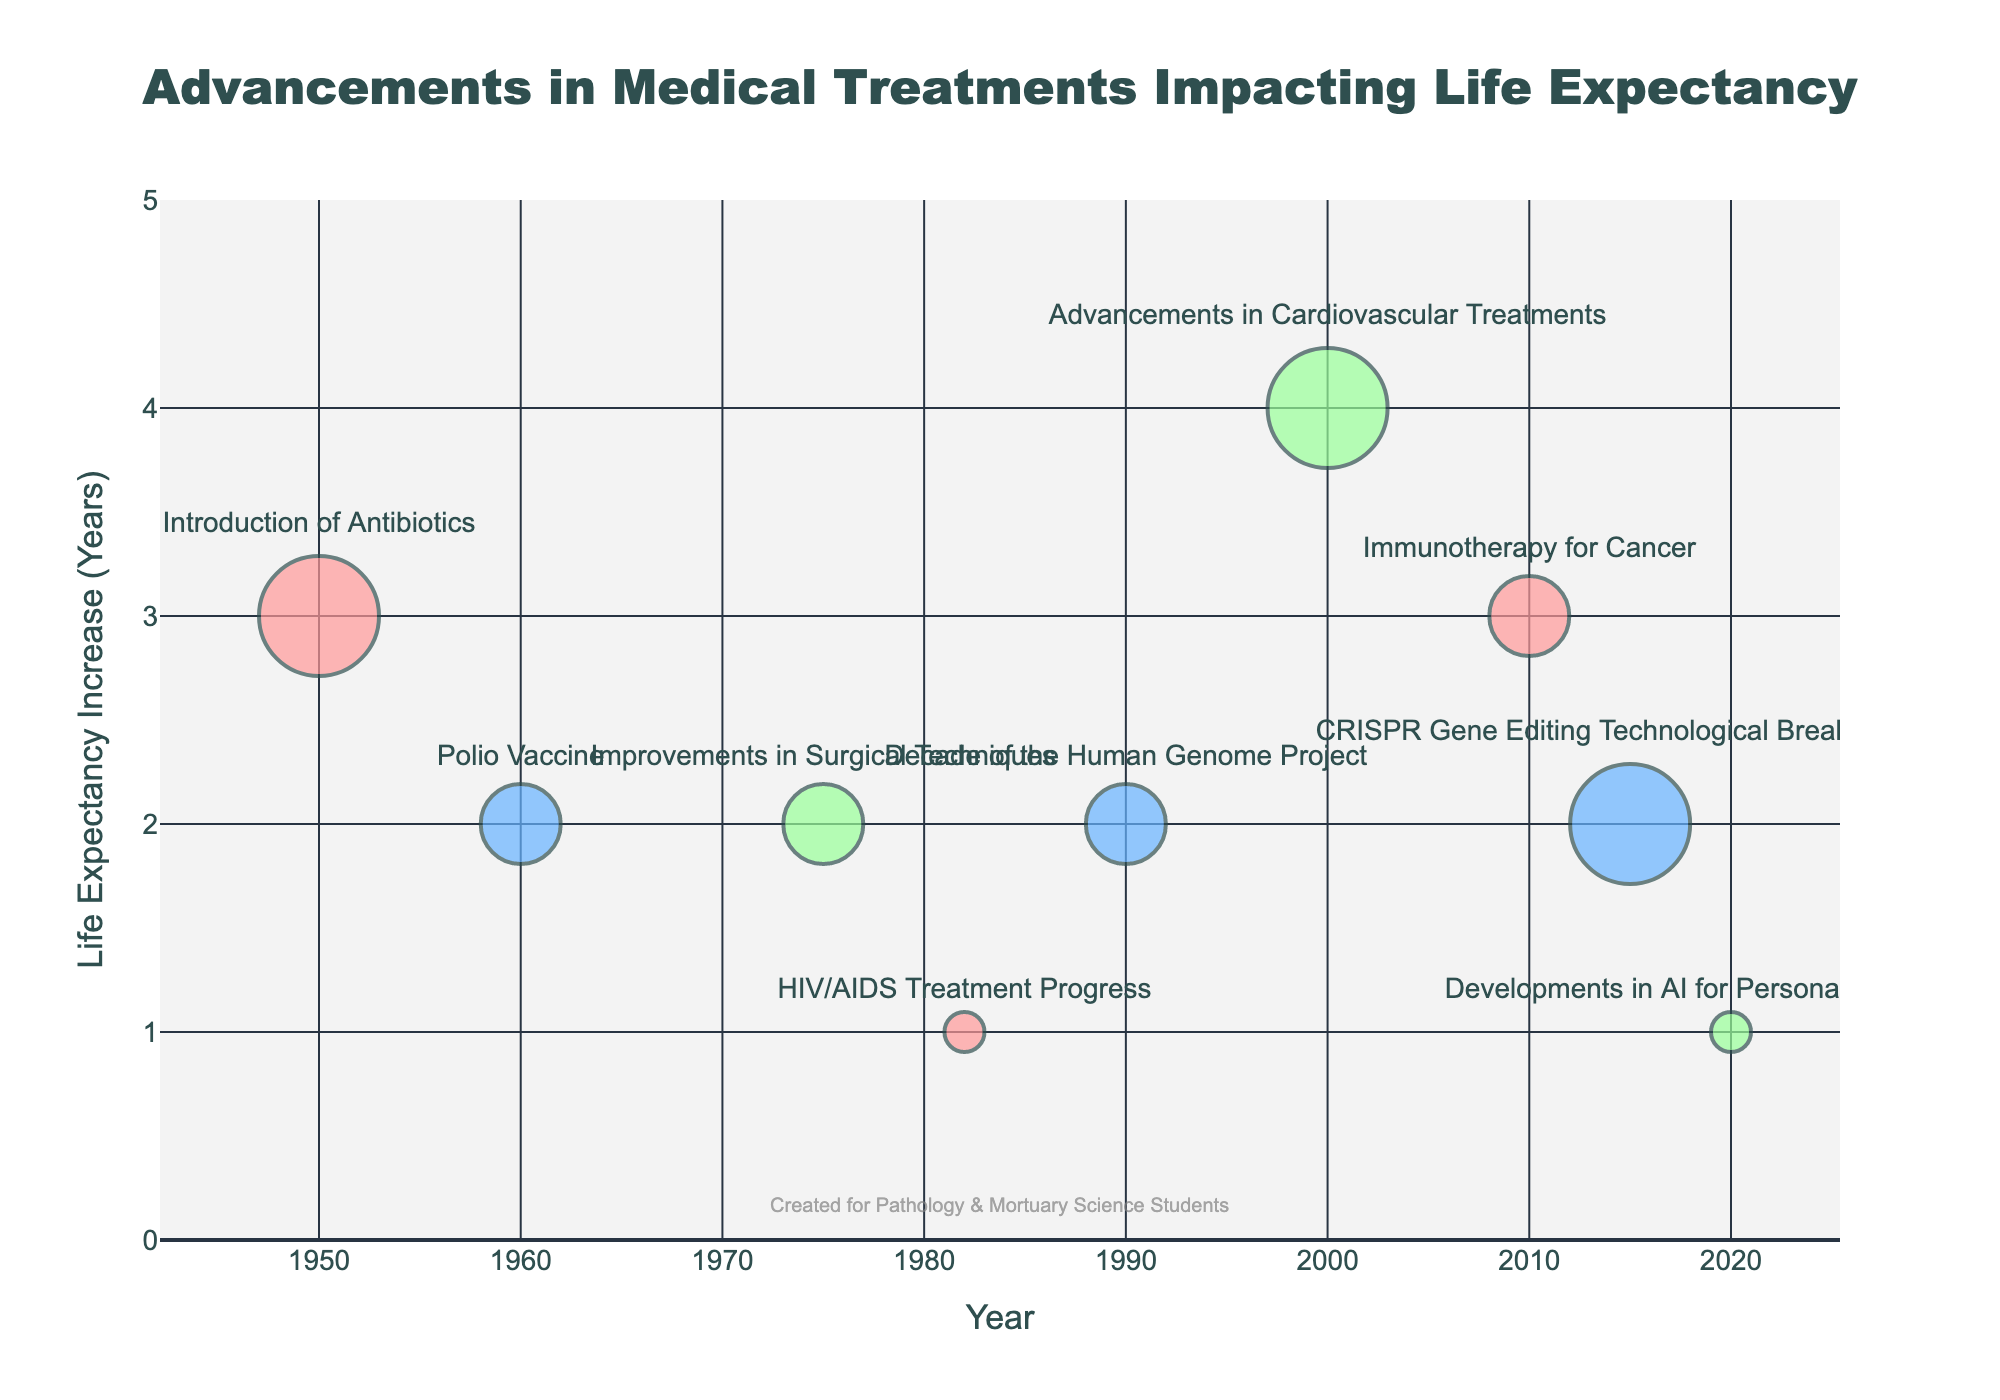What is the total life expectancy increase in the 1950s based on the medical treatments shown? The figure shows the introduction of antibiotics in 1950 leading to a life expectancy increase of 3 years. Summing up the individual increases yields the total.
Answer: 3 years Which medical treatment is represented by the largest bubble in the 2000s? The largest bubbles represent high impact measures. The treatment depicted by the largest bubble in the 2000s is advancements in cardiovascular treatments.
Answer: Advancements in Cardiovascular Treatments What is the average life expectancy increase over all the treatments shown in the figure? Summing the life expectancy increases (3, 2, 2, 1, 2, 4, 3, 2, 1) gives a total of 20 years. There are 9 data points, so 20 divided by 9 gives the average.
Answer: 2.22 years Which decade saw the most significant single improvement in life expectancy and what was the treatment? The size of the bubble indicates the magnitude of improvement, and the highest bubble corresponds to advancements in cardiovascular treatments in 2000.
Answer: 2000s, Advancements in Cardiovascular Treatments What is the combined life expectancy increase from treatments introduced after the year 2000? The figure shows advancements in cardiovascular treatments (4 years), immunotherapy for cancer (3 years), CRISPR gene editing (2 years), and developments in AI for personalized medicine (1 year). The sum is 4 + 3 + 2 + 1.
Answer: 10 years What impact measure corresponds to the introduction of antibiotics according to the bubble size? The impact measure can be inferred from the size of the bubble. The largest bubbles represent a high impact, and the antibiotics introduction has the largest bubble.
Answer: High How does the impact measure of HIV/AIDS treatment progress compare to that of CRISPR gene editing? HIV/AIDS treatment progress is indicated by a smaller bubble compared to CRISPR gene editing, signifying a lower impact measure.
Answer: Lower Which treatment had the smallest visual impact on life expectancy in terms of bubble size? The smallest bubbles indicate a low-impact measure, represented by developments in AI for personalized medicine and HIV/AIDS treatment progress.
Answer: Developments in AI for Personalized Medicine, HIV/AIDS Treatment Progress How many treatments in the figure led to a life expectancy increase of 2 years? There are four treatments indicated with a value of 2 years: the polio vaccine, improvements in surgical techniques, the Human Genome Project, and CRISPR gene editing.
Answer: Four 